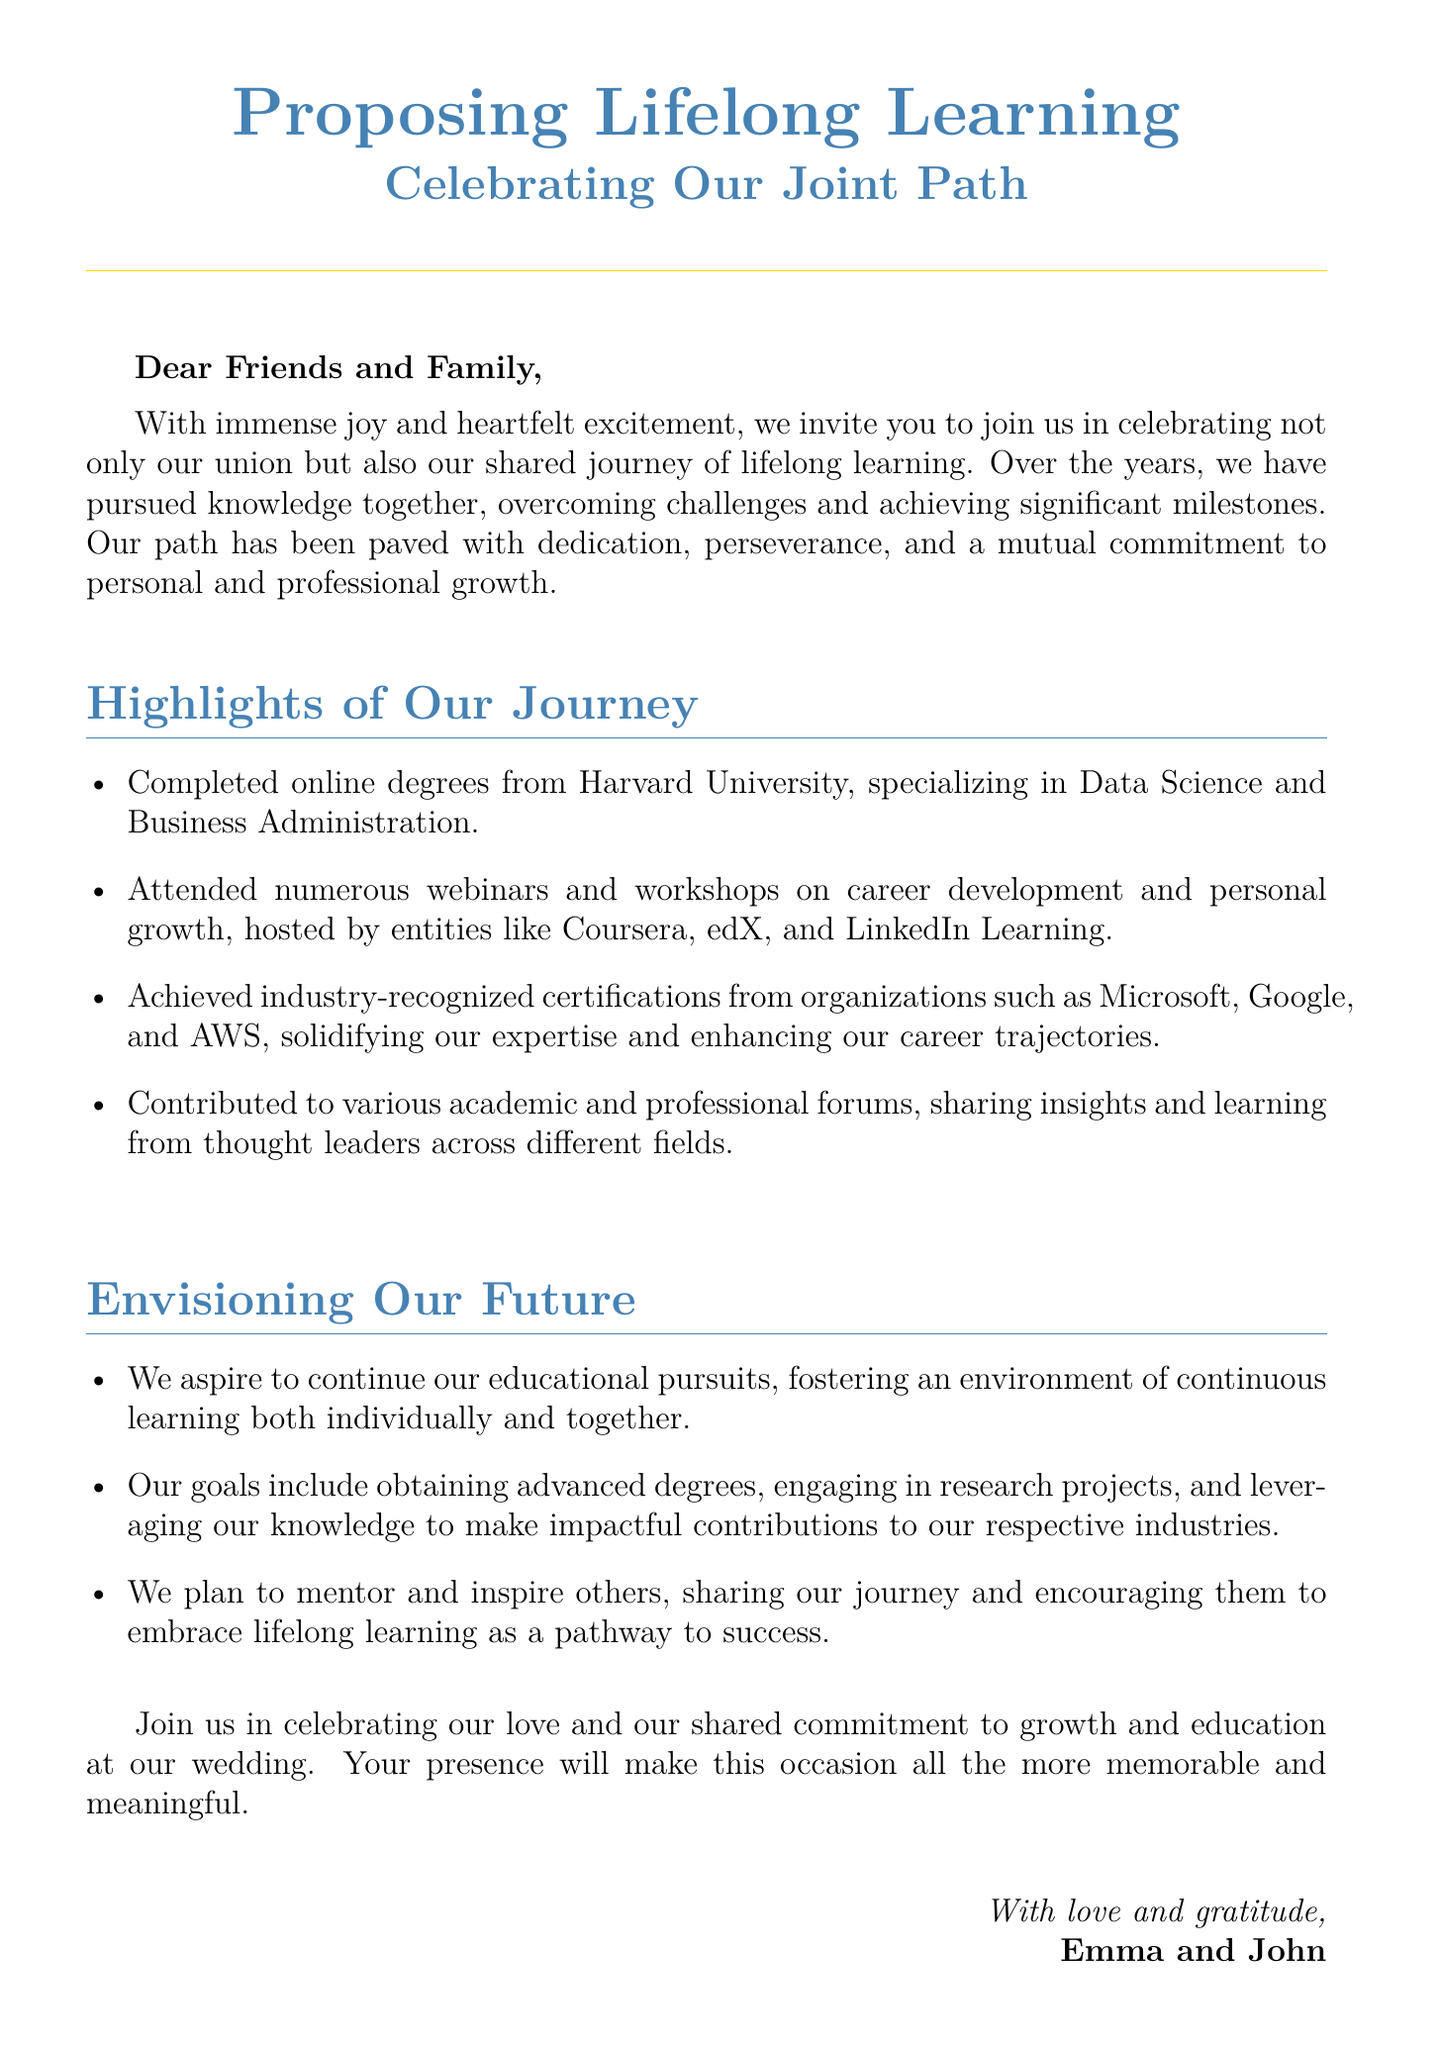What is the main theme of the celebration? The main theme is "Lifelong Learning" as stated in the invitation.
Answer: Lifelong Learning Who are the couple getting married? The couple is mentioned at the end of the document.
Answer: Emma and John What degrees did the couple complete online? The degrees are specified in the highlights of their journey.
Answer: Data Science and Business Administration Which organizations offered certifications mentioned in the document? The organizations listed in the itemized achievements provide certifications.
Answer: Microsoft, Google, AWS What do the couple aspire to obtain in the future? The aspirations for the future include further academic achievements.
Answer: Advanced degrees What type of events have the couple attended for personal development? The events they attended are specified in a list format.
Answer: Webinars and workshops What is the purpose of the wedding celebration as stated in the document? The purpose includes a commitment to education and personal growth.
Answer: Celebrating love and growth Who is invited to celebrate the couple's journey? The invitation specifically addresses the audience.
Answer: Friends and Family 